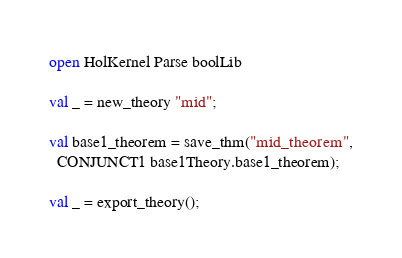<code> <loc_0><loc_0><loc_500><loc_500><_SML_>open HolKernel Parse boolLib

val _ = new_theory "mid";

val base1_theorem = save_thm("mid_theorem",
  CONJUNCT1 base1Theory.base1_theorem);

val _ = export_theory();
</code> 